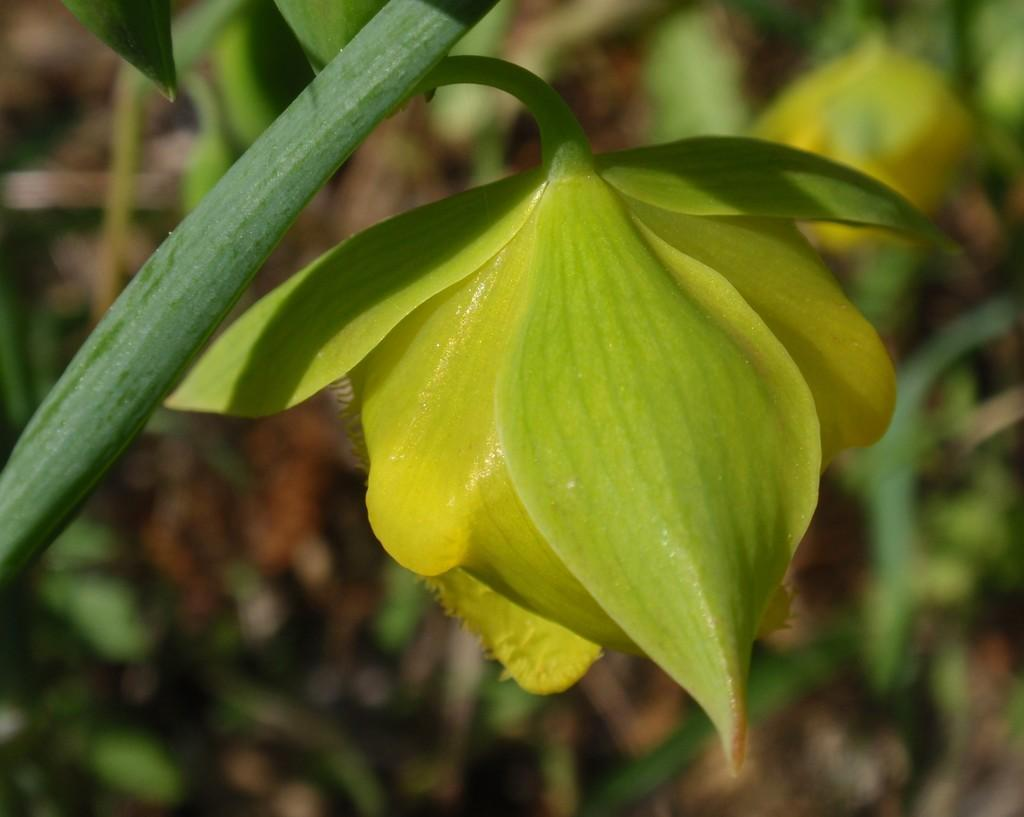What type of living organism can be seen in the image? There is a plant in the image. What specific part of the plant is visible in the image? There is a flower in the image. What type of shoes is the plant wearing in the image? There are no shoes present in the image, as the subject is a plant. 